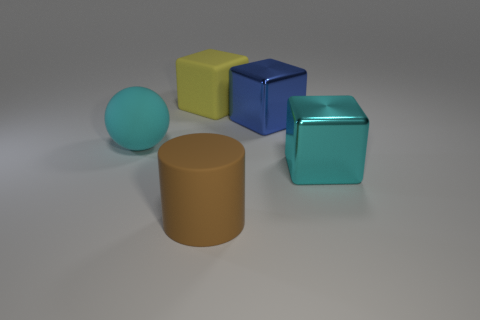What is the material of the big object that is the same color as the big sphere?
Offer a very short reply. Metal. What shape is the cyan object that is the same material as the brown thing?
Offer a very short reply. Sphere. Is the number of large cyan things that are behind the sphere greater than the number of large cyan blocks left of the blue metal cube?
Ensure brevity in your answer.  No. What number of objects are either blue objects or cyan spheres?
Provide a short and direct response. 2. How many other things are the same color as the rubber cylinder?
Give a very brief answer. 0. There is a brown matte thing that is the same size as the cyan metal block; what shape is it?
Give a very brief answer. Cylinder. The cube that is left of the rubber cylinder is what color?
Your response must be concise. Yellow. What number of things are either shiny blocks in front of the large sphere or big cubes in front of the cyan rubber sphere?
Give a very brief answer. 1. Does the blue object have the same size as the cyan block?
Your response must be concise. Yes. How many cubes are tiny yellow metallic things or big blue shiny things?
Your answer should be very brief. 1. 